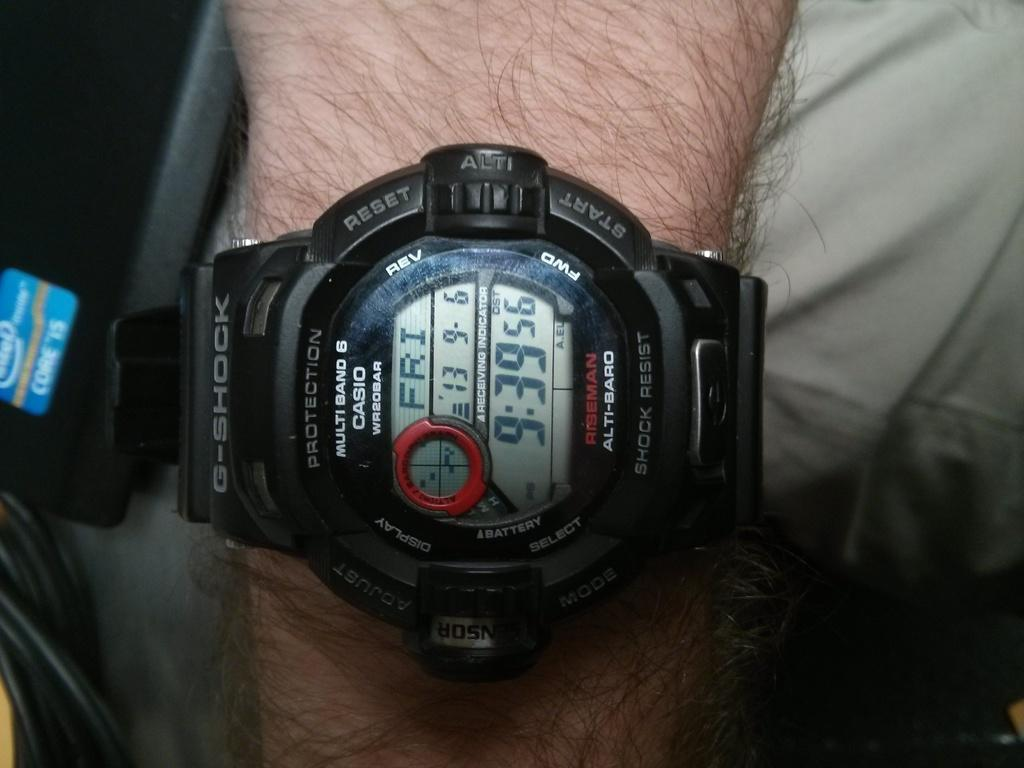<image>
Provide a brief description of the given image. A black casio watch shows the time as "9:39." 